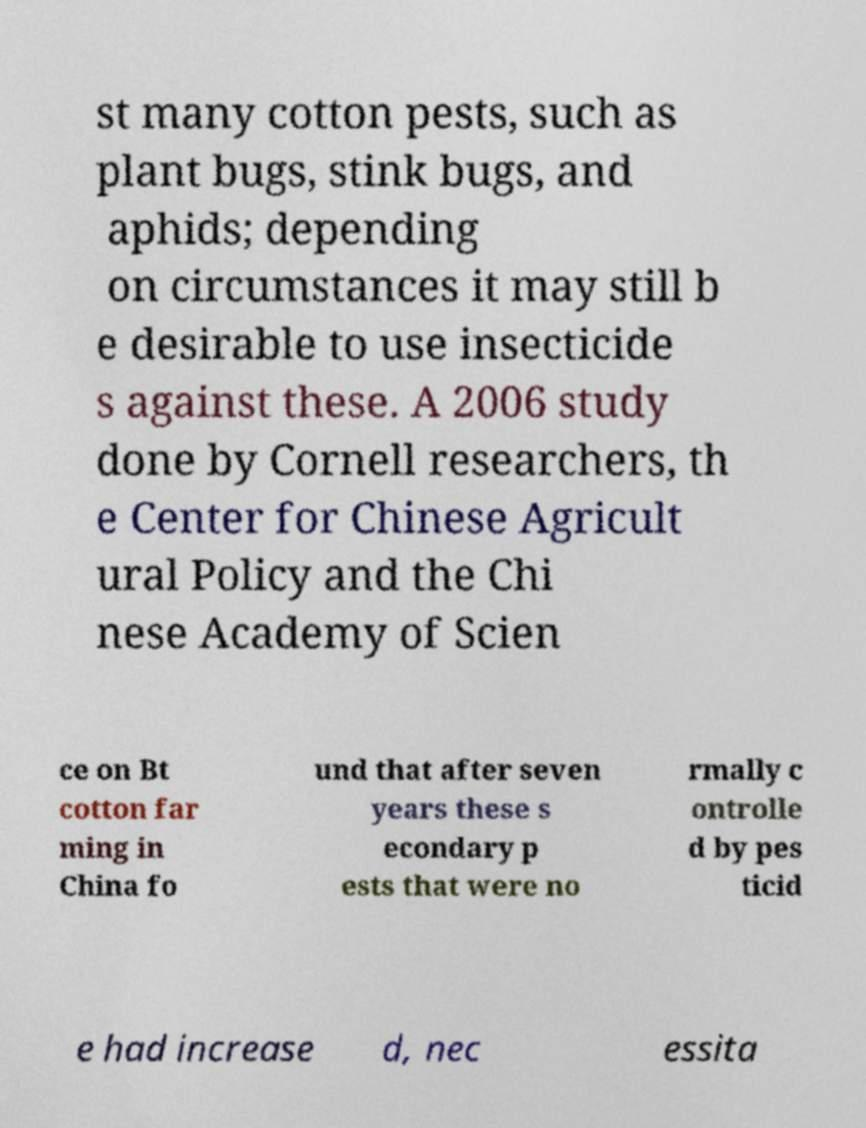Can you read and provide the text displayed in the image?This photo seems to have some interesting text. Can you extract and type it out for me? st many cotton pests, such as plant bugs, stink bugs, and aphids; depending on circumstances it may still b e desirable to use insecticide s against these. A 2006 study done by Cornell researchers, th e Center for Chinese Agricult ural Policy and the Chi nese Academy of Scien ce on Bt cotton far ming in China fo und that after seven years these s econdary p ests that were no rmally c ontrolle d by pes ticid e had increase d, nec essita 